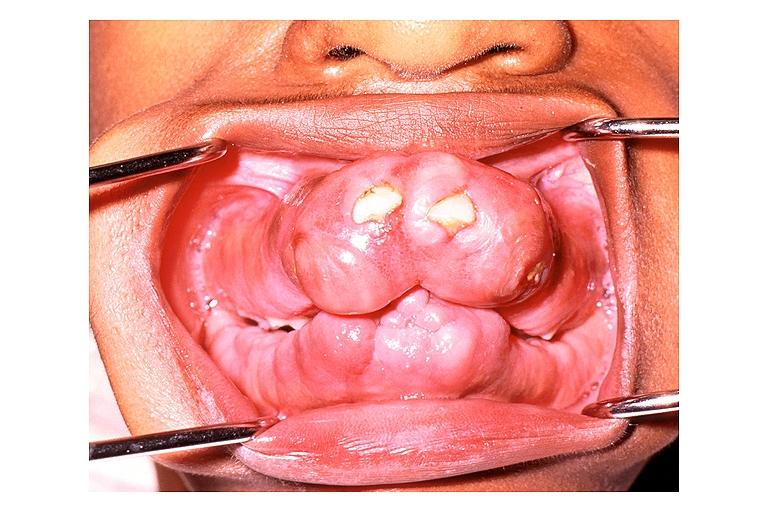s oral present?
Answer the question using a single word or phrase. Yes 